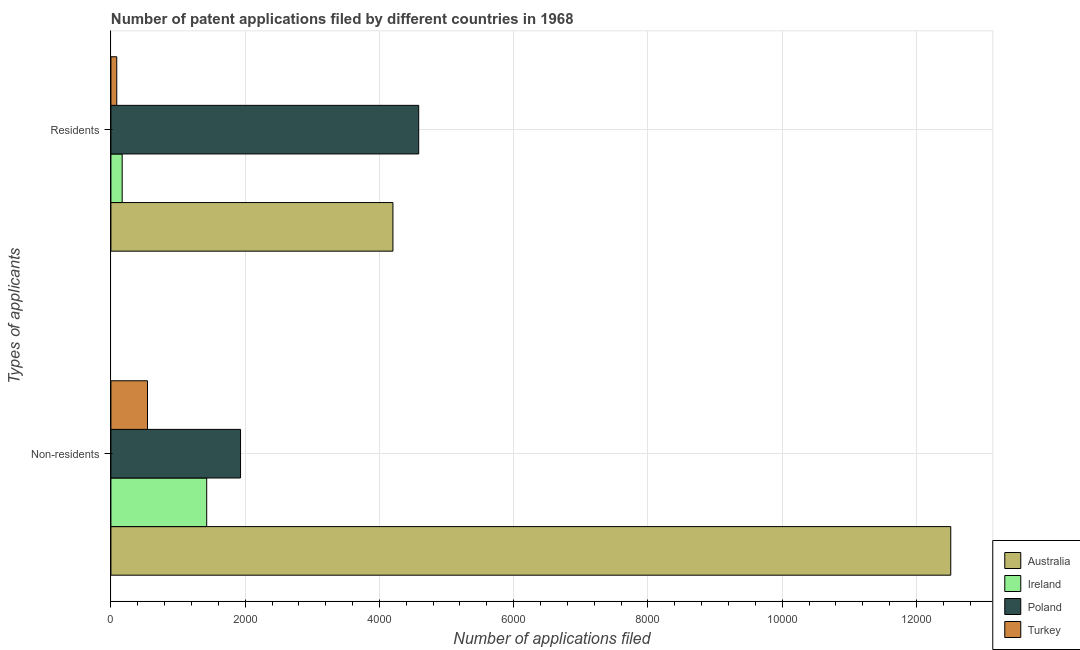How many groups of bars are there?
Ensure brevity in your answer.  2. Are the number of bars per tick equal to the number of legend labels?
Give a very brief answer. Yes. Are the number of bars on each tick of the Y-axis equal?
Provide a short and direct response. Yes. How many bars are there on the 2nd tick from the top?
Give a very brief answer. 4. What is the label of the 1st group of bars from the top?
Your answer should be compact. Residents. What is the number of patent applications by residents in Turkey?
Your answer should be compact. 87. Across all countries, what is the maximum number of patent applications by non residents?
Ensure brevity in your answer.  1.25e+04. Across all countries, what is the minimum number of patent applications by residents?
Your response must be concise. 87. In which country was the number of patent applications by residents maximum?
Your answer should be very brief. Poland. In which country was the number of patent applications by residents minimum?
Offer a very short reply. Turkey. What is the total number of patent applications by non residents in the graph?
Ensure brevity in your answer.  1.64e+04. What is the difference between the number of patent applications by non residents in Poland and that in Turkey?
Ensure brevity in your answer.  1386. What is the difference between the number of patent applications by residents in Poland and the number of patent applications by non residents in Australia?
Your answer should be compact. -7926. What is the average number of patent applications by residents per country?
Provide a short and direct response. 2260.25. What is the difference between the number of patent applications by non residents and number of patent applications by residents in Poland?
Your response must be concise. -2654. What is the ratio of the number of patent applications by non residents in Poland to that in Turkey?
Your answer should be very brief. 3.54. Is the number of patent applications by non residents in Ireland less than that in Turkey?
Ensure brevity in your answer.  No. What does the 3rd bar from the top in Non-residents represents?
Your answer should be very brief. Ireland. Are all the bars in the graph horizontal?
Offer a very short reply. Yes. How many countries are there in the graph?
Your answer should be compact. 4. Are the values on the major ticks of X-axis written in scientific E-notation?
Keep it short and to the point. No. Does the graph contain any zero values?
Keep it short and to the point. No. Where does the legend appear in the graph?
Provide a succinct answer. Bottom right. How many legend labels are there?
Ensure brevity in your answer.  4. What is the title of the graph?
Your answer should be compact. Number of patent applications filed by different countries in 1968. Does "High income: OECD" appear as one of the legend labels in the graph?
Offer a very short reply. No. What is the label or title of the X-axis?
Make the answer very short. Number of applications filed. What is the label or title of the Y-axis?
Ensure brevity in your answer.  Types of applicants. What is the Number of applications filed in Australia in Non-residents?
Provide a short and direct response. 1.25e+04. What is the Number of applications filed in Ireland in Non-residents?
Your response must be concise. 1427. What is the Number of applications filed in Poland in Non-residents?
Make the answer very short. 1931. What is the Number of applications filed in Turkey in Non-residents?
Offer a very short reply. 545. What is the Number of applications filed in Australia in Residents?
Keep it short and to the point. 4201. What is the Number of applications filed in Ireland in Residents?
Your answer should be very brief. 168. What is the Number of applications filed of Poland in Residents?
Give a very brief answer. 4585. What is the Number of applications filed in Turkey in Residents?
Offer a very short reply. 87. Across all Types of applicants, what is the maximum Number of applications filed of Australia?
Keep it short and to the point. 1.25e+04. Across all Types of applicants, what is the maximum Number of applications filed in Ireland?
Your response must be concise. 1427. Across all Types of applicants, what is the maximum Number of applications filed in Poland?
Provide a succinct answer. 4585. Across all Types of applicants, what is the maximum Number of applications filed in Turkey?
Your answer should be very brief. 545. Across all Types of applicants, what is the minimum Number of applications filed of Australia?
Provide a short and direct response. 4201. Across all Types of applicants, what is the minimum Number of applications filed of Ireland?
Make the answer very short. 168. Across all Types of applicants, what is the minimum Number of applications filed in Poland?
Make the answer very short. 1931. Across all Types of applicants, what is the minimum Number of applications filed of Turkey?
Your response must be concise. 87. What is the total Number of applications filed in Australia in the graph?
Make the answer very short. 1.67e+04. What is the total Number of applications filed of Ireland in the graph?
Give a very brief answer. 1595. What is the total Number of applications filed in Poland in the graph?
Provide a succinct answer. 6516. What is the total Number of applications filed in Turkey in the graph?
Ensure brevity in your answer.  632. What is the difference between the Number of applications filed in Australia in Non-residents and that in Residents?
Keep it short and to the point. 8310. What is the difference between the Number of applications filed of Ireland in Non-residents and that in Residents?
Provide a short and direct response. 1259. What is the difference between the Number of applications filed of Poland in Non-residents and that in Residents?
Make the answer very short. -2654. What is the difference between the Number of applications filed of Turkey in Non-residents and that in Residents?
Your answer should be compact. 458. What is the difference between the Number of applications filed in Australia in Non-residents and the Number of applications filed in Ireland in Residents?
Provide a succinct answer. 1.23e+04. What is the difference between the Number of applications filed of Australia in Non-residents and the Number of applications filed of Poland in Residents?
Ensure brevity in your answer.  7926. What is the difference between the Number of applications filed of Australia in Non-residents and the Number of applications filed of Turkey in Residents?
Provide a short and direct response. 1.24e+04. What is the difference between the Number of applications filed in Ireland in Non-residents and the Number of applications filed in Poland in Residents?
Keep it short and to the point. -3158. What is the difference between the Number of applications filed in Ireland in Non-residents and the Number of applications filed in Turkey in Residents?
Your answer should be very brief. 1340. What is the difference between the Number of applications filed in Poland in Non-residents and the Number of applications filed in Turkey in Residents?
Ensure brevity in your answer.  1844. What is the average Number of applications filed in Australia per Types of applicants?
Provide a short and direct response. 8356. What is the average Number of applications filed in Ireland per Types of applicants?
Keep it short and to the point. 797.5. What is the average Number of applications filed of Poland per Types of applicants?
Provide a short and direct response. 3258. What is the average Number of applications filed of Turkey per Types of applicants?
Your response must be concise. 316. What is the difference between the Number of applications filed of Australia and Number of applications filed of Ireland in Non-residents?
Offer a terse response. 1.11e+04. What is the difference between the Number of applications filed in Australia and Number of applications filed in Poland in Non-residents?
Your answer should be very brief. 1.06e+04. What is the difference between the Number of applications filed in Australia and Number of applications filed in Turkey in Non-residents?
Offer a very short reply. 1.20e+04. What is the difference between the Number of applications filed of Ireland and Number of applications filed of Poland in Non-residents?
Provide a short and direct response. -504. What is the difference between the Number of applications filed of Ireland and Number of applications filed of Turkey in Non-residents?
Give a very brief answer. 882. What is the difference between the Number of applications filed in Poland and Number of applications filed in Turkey in Non-residents?
Ensure brevity in your answer.  1386. What is the difference between the Number of applications filed in Australia and Number of applications filed in Ireland in Residents?
Your answer should be compact. 4033. What is the difference between the Number of applications filed of Australia and Number of applications filed of Poland in Residents?
Your answer should be compact. -384. What is the difference between the Number of applications filed of Australia and Number of applications filed of Turkey in Residents?
Offer a terse response. 4114. What is the difference between the Number of applications filed in Ireland and Number of applications filed in Poland in Residents?
Keep it short and to the point. -4417. What is the difference between the Number of applications filed of Poland and Number of applications filed of Turkey in Residents?
Ensure brevity in your answer.  4498. What is the ratio of the Number of applications filed of Australia in Non-residents to that in Residents?
Ensure brevity in your answer.  2.98. What is the ratio of the Number of applications filed of Ireland in Non-residents to that in Residents?
Keep it short and to the point. 8.49. What is the ratio of the Number of applications filed in Poland in Non-residents to that in Residents?
Your response must be concise. 0.42. What is the ratio of the Number of applications filed in Turkey in Non-residents to that in Residents?
Your answer should be compact. 6.26. What is the difference between the highest and the second highest Number of applications filed of Australia?
Offer a very short reply. 8310. What is the difference between the highest and the second highest Number of applications filed in Ireland?
Provide a succinct answer. 1259. What is the difference between the highest and the second highest Number of applications filed in Poland?
Provide a succinct answer. 2654. What is the difference between the highest and the second highest Number of applications filed in Turkey?
Provide a succinct answer. 458. What is the difference between the highest and the lowest Number of applications filed in Australia?
Provide a short and direct response. 8310. What is the difference between the highest and the lowest Number of applications filed of Ireland?
Keep it short and to the point. 1259. What is the difference between the highest and the lowest Number of applications filed in Poland?
Your answer should be very brief. 2654. What is the difference between the highest and the lowest Number of applications filed of Turkey?
Ensure brevity in your answer.  458. 